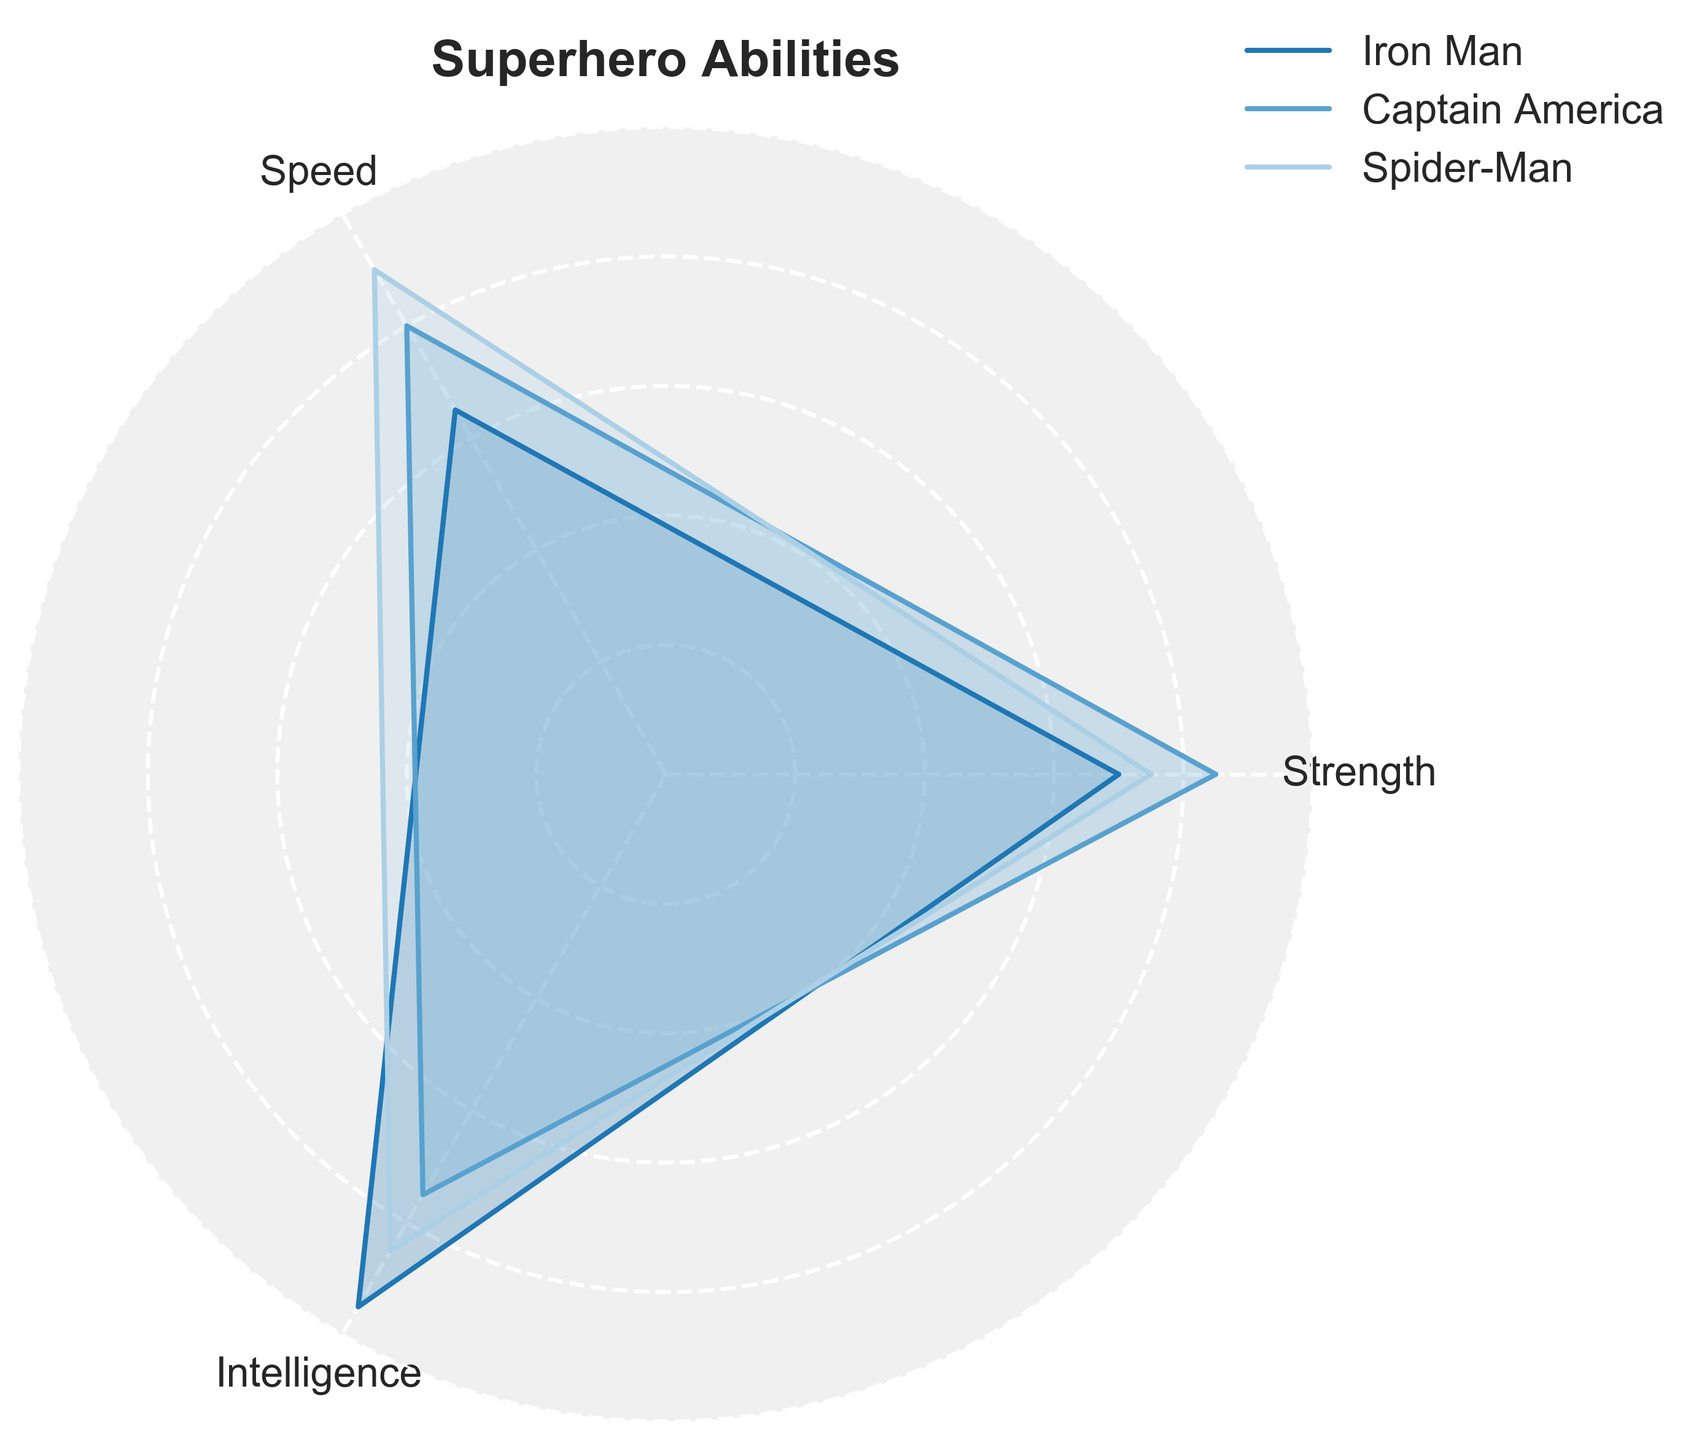What is the title of the radar chart? The title of the radar chart is written at the top of the figure. It reads "Superhero Abilities".
Answer: Superhero Abilities Which superhero has the highest value in Strength? By looking at the radar chart, the character with the line going furthest along the Strength axis is identified. The furthest line corresponds to "Spider-Man".
Answer: Spider-Man Who has the highest score in Speed? By inspecting the Speed axis, the superhero whose line extends furthest out from the center indicates the highest speed. This corresponds to "Spider-Man".
Answer: Spider-Man Which superhero has the lowest intelligence among the three shown? To find the superhero with the lowest intelligence, compare the values along the Intelligence axis. The superhero with the shortest line on this axis is "Captain America".
Answer: Captain America What are the Strength values for Iron Man and Captain America? Locate the lines for Iron Man and Captain America and read their respective lengths along the Strength axis. Iron Man's line is at 70, and Captain America's line is at 85.
Answer: Iron Man: 70, Captain America: 85 How does Spider-Man's Speed compare to Iron Man's Speed? Look at the Speed axis values for Spider-Man and Iron Man. Spider-Man's Speed value is 90, while Iron Man's is 65. Thus, Spider-Man's Speed is greater than Iron Man's Speed.
Answer: Spider-Man's Speed is greater Arrange the superheroes in descending order of Intelligence. To order the superheroes by Intelligence, compare their values along the Intelligence axis. Spider-Man (85), Iron Man (95), Captain America (75). So, the order is Iron Man, Spider-Man, Captain America.
Answer: Iron Man, Spider-Man, Captain America What is the combined Strength score of all three superheroes? Add the Strength values for Iron Man, Captain America, and Spider-Man. 70 (Iron Man) + 85 (Captain America) + 75 (Spider-Man) equals 230.
Answer: 230 Which superhero has the most balanced abilities across all three categories? Check which superhero has values that are comparatively close across all three categories. Spider-Man has values of 75 (Strength), 90 (Speed), and 85 (Intelligence), indicating a balanced distribution.
Answer: Spider-Man 